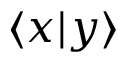<formula> <loc_0><loc_0><loc_500><loc_500>\langle x | y \rangle</formula> 